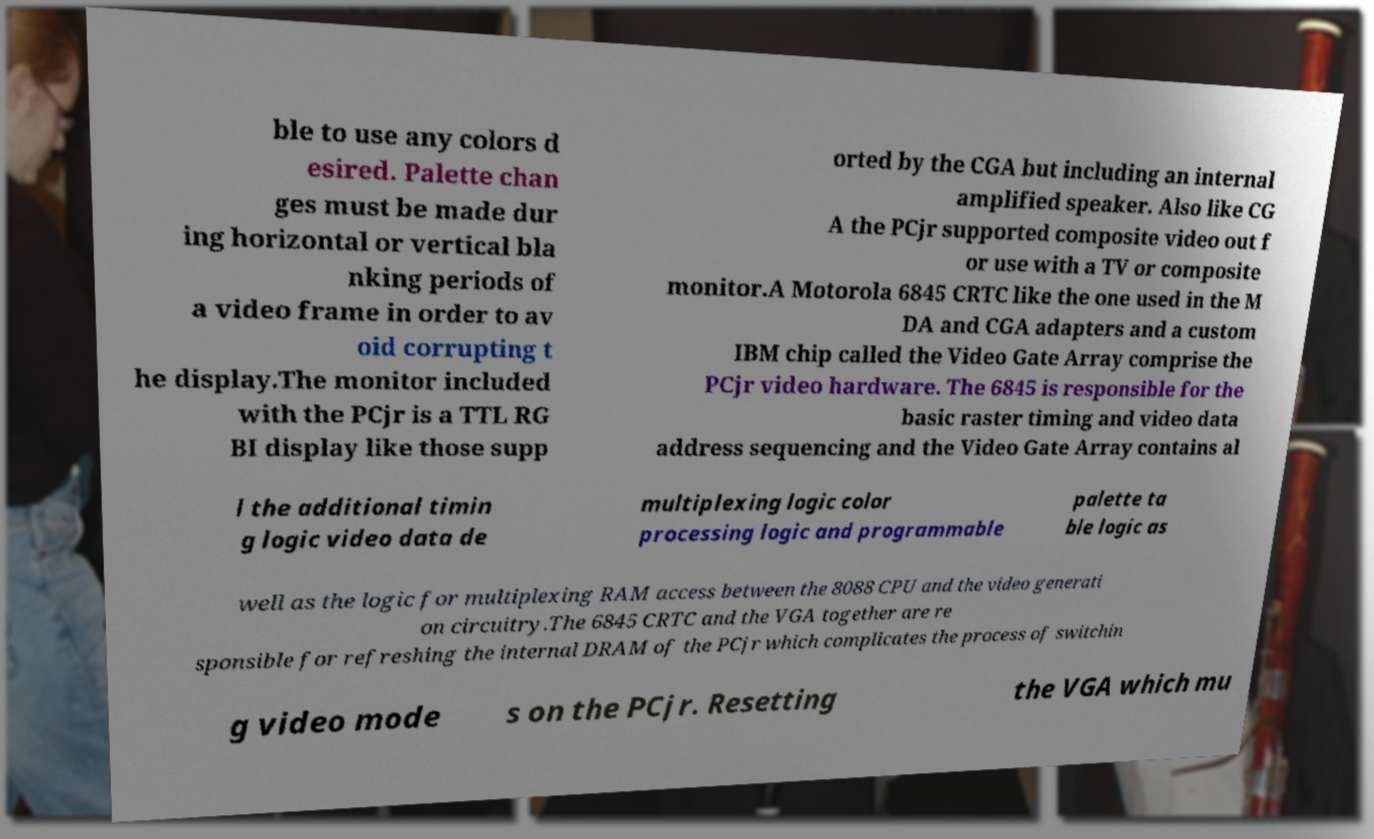Can you accurately transcribe the text from the provided image for me? ble to use any colors d esired. Palette chan ges must be made dur ing horizontal or vertical bla nking periods of a video frame in order to av oid corrupting t he display.The monitor included with the PCjr is a TTL RG BI display like those supp orted by the CGA but including an internal amplified speaker. Also like CG A the PCjr supported composite video out f or use with a TV or composite monitor.A Motorola 6845 CRTC like the one used in the M DA and CGA adapters and a custom IBM chip called the Video Gate Array comprise the PCjr video hardware. The 6845 is responsible for the basic raster timing and video data address sequencing and the Video Gate Array contains al l the additional timin g logic video data de multiplexing logic color processing logic and programmable palette ta ble logic as well as the logic for multiplexing RAM access between the 8088 CPU and the video generati on circuitry.The 6845 CRTC and the VGA together are re sponsible for refreshing the internal DRAM of the PCjr which complicates the process of switchin g video mode s on the PCjr. Resetting the VGA which mu 